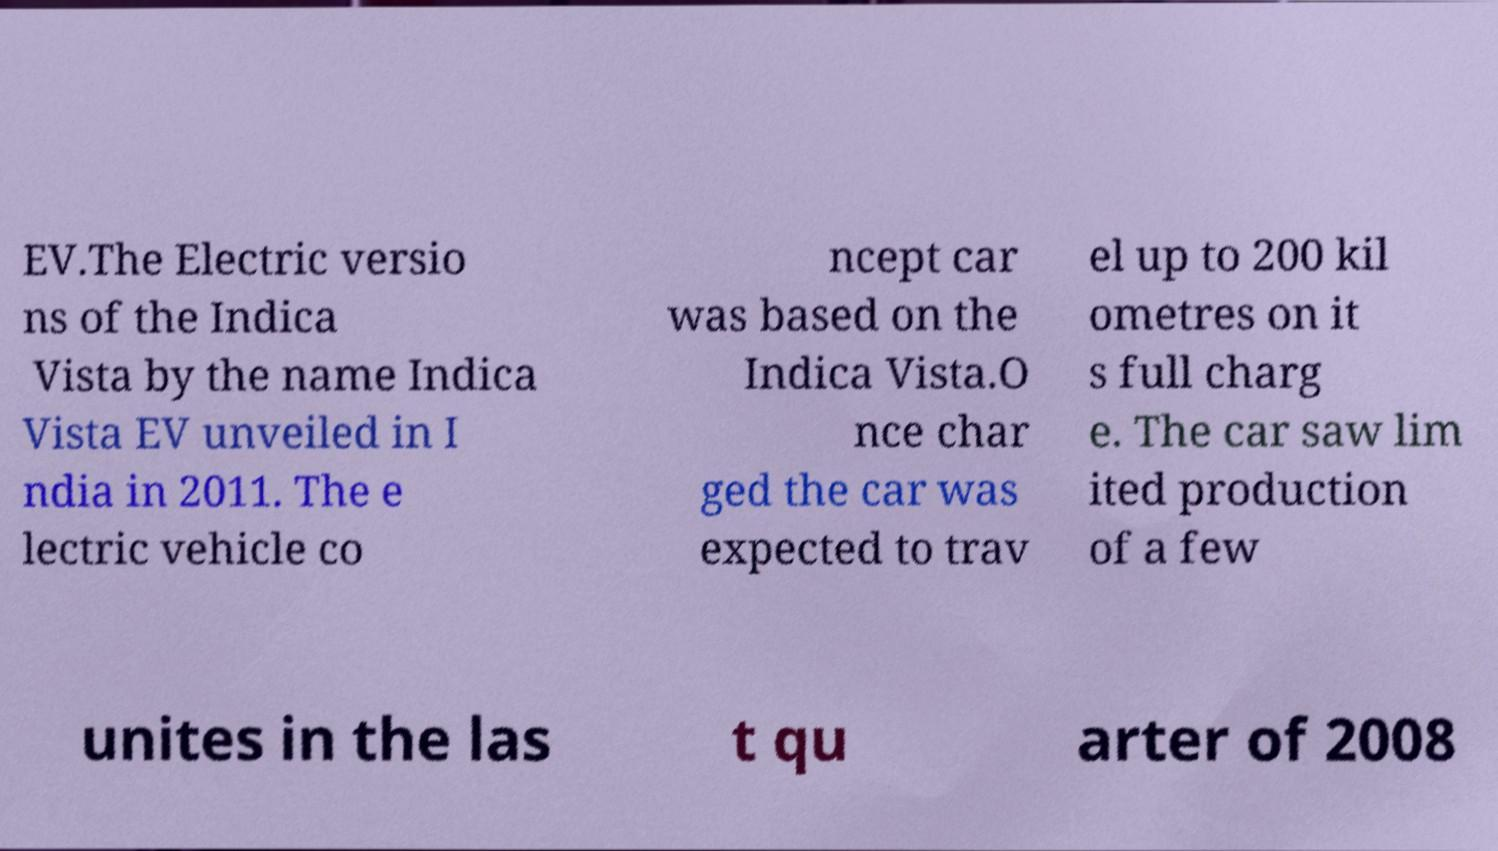There's text embedded in this image that I need extracted. Can you transcribe it verbatim? EV.The Electric versio ns of the Indica Vista by the name Indica Vista EV unveiled in I ndia in 2011. The e lectric vehicle co ncept car was based on the Indica Vista.O nce char ged the car was expected to trav el up to 200 kil ometres on it s full charg e. The car saw lim ited production of a few unites in the las t qu arter of 2008 